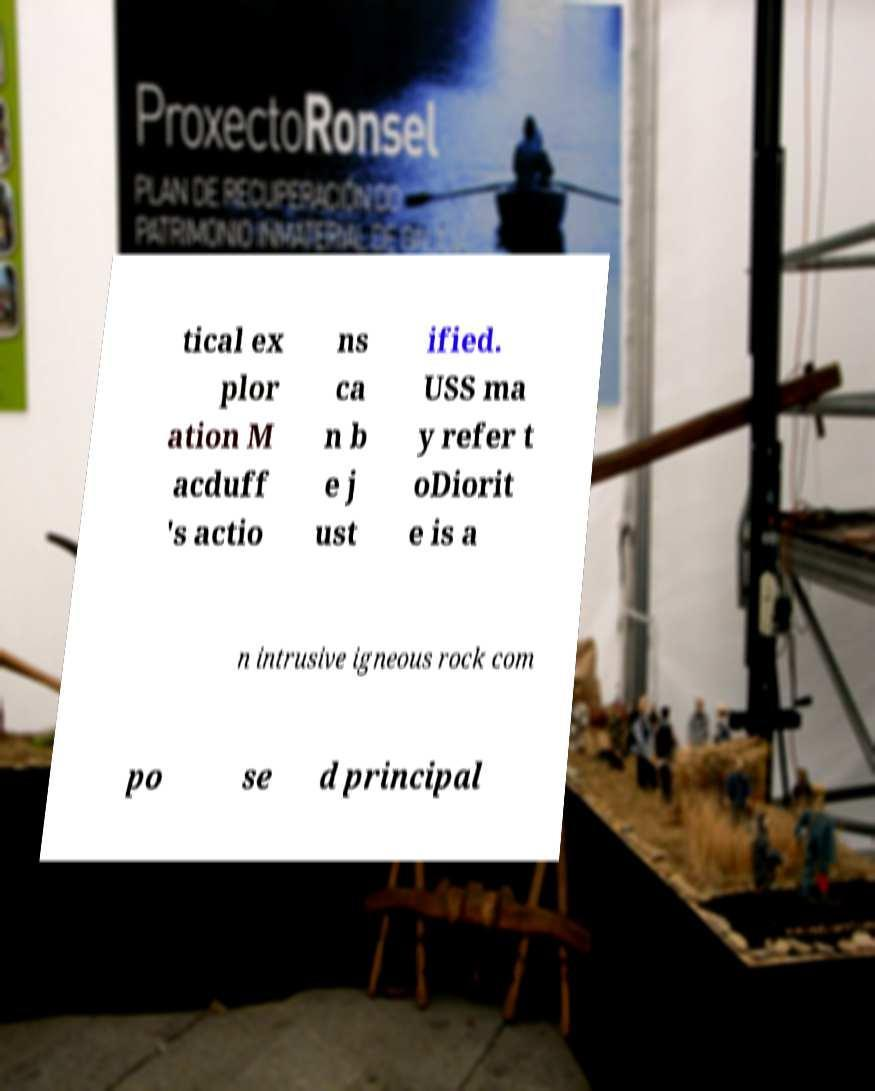Can you accurately transcribe the text from the provided image for me? tical ex plor ation M acduff 's actio ns ca n b e j ust ified. USS ma y refer t oDiorit e is a n intrusive igneous rock com po se d principal 